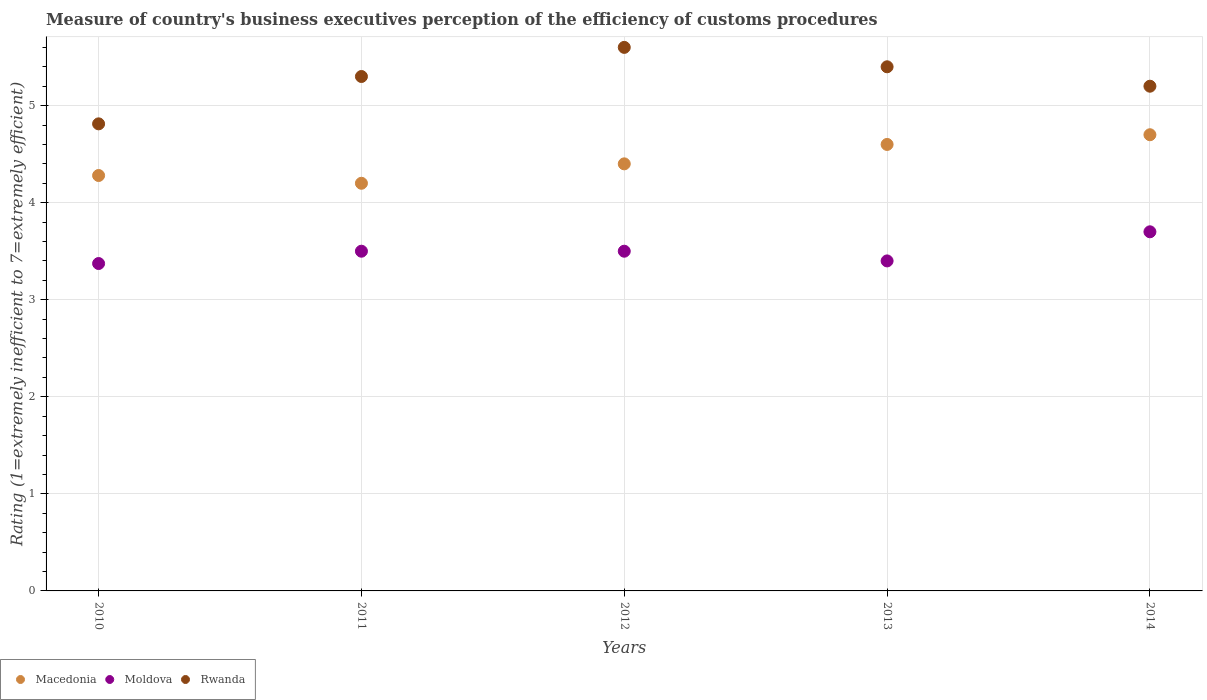Across all years, what is the minimum rating of the efficiency of customs procedure in Moldova?
Your answer should be very brief. 3.37. In which year was the rating of the efficiency of customs procedure in Rwanda minimum?
Make the answer very short. 2010. What is the total rating of the efficiency of customs procedure in Moldova in the graph?
Give a very brief answer. 17.47. What is the difference between the rating of the efficiency of customs procedure in Rwanda in 2011 and that in 2012?
Provide a short and direct response. -0.3. What is the difference between the rating of the efficiency of customs procedure in Moldova in 2014 and the rating of the efficiency of customs procedure in Macedonia in 2012?
Provide a succinct answer. -0.7. What is the average rating of the efficiency of customs procedure in Rwanda per year?
Your response must be concise. 5.26. In the year 2012, what is the difference between the rating of the efficiency of customs procedure in Macedonia and rating of the efficiency of customs procedure in Rwanda?
Provide a short and direct response. -1.2. In how many years, is the rating of the efficiency of customs procedure in Moldova greater than 2.2?
Your answer should be compact. 5. What is the ratio of the rating of the efficiency of customs procedure in Rwanda in 2010 to that in 2013?
Offer a very short reply. 0.89. Is the rating of the efficiency of customs procedure in Rwanda in 2011 less than that in 2012?
Provide a succinct answer. Yes. What is the difference between the highest and the second highest rating of the efficiency of customs procedure in Rwanda?
Provide a succinct answer. 0.2. What is the difference between the highest and the lowest rating of the efficiency of customs procedure in Rwanda?
Make the answer very short. 0.79. Does the rating of the efficiency of customs procedure in Moldova monotonically increase over the years?
Offer a terse response. No. Are the values on the major ticks of Y-axis written in scientific E-notation?
Your response must be concise. No. Does the graph contain any zero values?
Provide a short and direct response. No. Does the graph contain grids?
Your answer should be compact. Yes. How many legend labels are there?
Ensure brevity in your answer.  3. What is the title of the graph?
Make the answer very short. Measure of country's business executives perception of the efficiency of customs procedures. What is the label or title of the X-axis?
Your answer should be compact. Years. What is the label or title of the Y-axis?
Your answer should be very brief. Rating (1=extremely inefficient to 7=extremely efficient). What is the Rating (1=extremely inefficient to 7=extremely efficient) of Macedonia in 2010?
Give a very brief answer. 4.28. What is the Rating (1=extremely inefficient to 7=extremely efficient) of Moldova in 2010?
Your answer should be compact. 3.37. What is the Rating (1=extremely inefficient to 7=extremely efficient) of Rwanda in 2010?
Your answer should be very brief. 4.81. What is the Rating (1=extremely inefficient to 7=extremely efficient) of Macedonia in 2011?
Ensure brevity in your answer.  4.2. What is the Rating (1=extremely inefficient to 7=extremely efficient) in Moldova in 2011?
Offer a terse response. 3.5. What is the Rating (1=extremely inefficient to 7=extremely efficient) of Macedonia in 2014?
Keep it short and to the point. 4.7. What is the Rating (1=extremely inefficient to 7=extremely efficient) of Rwanda in 2014?
Your response must be concise. 5.2. Across all years, what is the maximum Rating (1=extremely inefficient to 7=extremely efficient) of Macedonia?
Give a very brief answer. 4.7. Across all years, what is the maximum Rating (1=extremely inefficient to 7=extremely efficient) in Moldova?
Your answer should be very brief. 3.7. Across all years, what is the maximum Rating (1=extremely inefficient to 7=extremely efficient) in Rwanda?
Provide a succinct answer. 5.6. Across all years, what is the minimum Rating (1=extremely inefficient to 7=extremely efficient) in Macedonia?
Provide a short and direct response. 4.2. Across all years, what is the minimum Rating (1=extremely inefficient to 7=extremely efficient) in Moldova?
Ensure brevity in your answer.  3.37. Across all years, what is the minimum Rating (1=extremely inefficient to 7=extremely efficient) of Rwanda?
Give a very brief answer. 4.81. What is the total Rating (1=extremely inefficient to 7=extremely efficient) of Macedonia in the graph?
Offer a terse response. 22.18. What is the total Rating (1=extremely inefficient to 7=extremely efficient) of Moldova in the graph?
Offer a terse response. 17.47. What is the total Rating (1=extremely inefficient to 7=extremely efficient) in Rwanda in the graph?
Your response must be concise. 26.31. What is the difference between the Rating (1=extremely inefficient to 7=extremely efficient) in Moldova in 2010 and that in 2011?
Offer a terse response. -0.13. What is the difference between the Rating (1=extremely inefficient to 7=extremely efficient) in Rwanda in 2010 and that in 2011?
Your answer should be compact. -0.49. What is the difference between the Rating (1=extremely inefficient to 7=extremely efficient) of Macedonia in 2010 and that in 2012?
Your answer should be compact. -0.12. What is the difference between the Rating (1=extremely inefficient to 7=extremely efficient) in Moldova in 2010 and that in 2012?
Provide a short and direct response. -0.13. What is the difference between the Rating (1=extremely inefficient to 7=extremely efficient) of Rwanda in 2010 and that in 2012?
Keep it short and to the point. -0.79. What is the difference between the Rating (1=extremely inefficient to 7=extremely efficient) of Macedonia in 2010 and that in 2013?
Make the answer very short. -0.32. What is the difference between the Rating (1=extremely inefficient to 7=extremely efficient) in Moldova in 2010 and that in 2013?
Make the answer very short. -0.03. What is the difference between the Rating (1=extremely inefficient to 7=extremely efficient) in Rwanda in 2010 and that in 2013?
Make the answer very short. -0.59. What is the difference between the Rating (1=extremely inefficient to 7=extremely efficient) of Macedonia in 2010 and that in 2014?
Keep it short and to the point. -0.42. What is the difference between the Rating (1=extremely inefficient to 7=extremely efficient) of Moldova in 2010 and that in 2014?
Make the answer very short. -0.33. What is the difference between the Rating (1=extremely inefficient to 7=extremely efficient) in Rwanda in 2010 and that in 2014?
Make the answer very short. -0.39. What is the difference between the Rating (1=extremely inefficient to 7=extremely efficient) in Moldova in 2011 and that in 2012?
Your answer should be compact. 0. What is the difference between the Rating (1=extremely inefficient to 7=extremely efficient) in Moldova in 2011 and that in 2013?
Make the answer very short. 0.1. What is the difference between the Rating (1=extremely inefficient to 7=extremely efficient) of Rwanda in 2011 and that in 2013?
Offer a terse response. -0.1. What is the difference between the Rating (1=extremely inefficient to 7=extremely efficient) of Rwanda in 2011 and that in 2014?
Provide a short and direct response. 0.1. What is the difference between the Rating (1=extremely inefficient to 7=extremely efficient) in Macedonia in 2012 and that in 2013?
Your answer should be compact. -0.2. What is the difference between the Rating (1=extremely inefficient to 7=extremely efficient) of Rwanda in 2012 and that in 2013?
Provide a short and direct response. 0.2. What is the difference between the Rating (1=extremely inefficient to 7=extremely efficient) in Macedonia in 2012 and that in 2014?
Your answer should be very brief. -0.3. What is the difference between the Rating (1=extremely inefficient to 7=extremely efficient) in Rwanda in 2012 and that in 2014?
Your response must be concise. 0.4. What is the difference between the Rating (1=extremely inefficient to 7=extremely efficient) of Macedonia in 2013 and that in 2014?
Offer a very short reply. -0.1. What is the difference between the Rating (1=extremely inefficient to 7=extremely efficient) in Moldova in 2013 and that in 2014?
Ensure brevity in your answer.  -0.3. What is the difference between the Rating (1=extremely inefficient to 7=extremely efficient) of Macedonia in 2010 and the Rating (1=extremely inefficient to 7=extremely efficient) of Moldova in 2011?
Offer a terse response. 0.78. What is the difference between the Rating (1=extremely inefficient to 7=extremely efficient) in Macedonia in 2010 and the Rating (1=extremely inefficient to 7=extremely efficient) in Rwanda in 2011?
Offer a terse response. -1.02. What is the difference between the Rating (1=extremely inefficient to 7=extremely efficient) of Moldova in 2010 and the Rating (1=extremely inefficient to 7=extremely efficient) of Rwanda in 2011?
Provide a succinct answer. -1.93. What is the difference between the Rating (1=extremely inefficient to 7=extremely efficient) in Macedonia in 2010 and the Rating (1=extremely inefficient to 7=extremely efficient) in Moldova in 2012?
Your response must be concise. 0.78. What is the difference between the Rating (1=extremely inefficient to 7=extremely efficient) of Macedonia in 2010 and the Rating (1=extremely inefficient to 7=extremely efficient) of Rwanda in 2012?
Your answer should be compact. -1.32. What is the difference between the Rating (1=extremely inefficient to 7=extremely efficient) of Moldova in 2010 and the Rating (1=extremely inefficient to 7=extremely efficient) of Rwanda in 2012?
Keep it short and to the point. -2.23. What is the difference between the Rating (1=extremely inefficient to 7=extremely efficient) of Macedonia in 2010 and the Rating (1=extremely inefficient to 7=extremely efficient) of Rwanda in 2013?
Your answer should be compact. -1.12. What is the difference between the Rating (1=extremely inefficient to 7=extremely efficient) of Moldova in 2010 and the Rating (1=extremely inefficient to 7=extremely efficient) of Rwanda in 2013?
Offer a terse response. -2.03. What is the difference between the Rating (1=extremely inefficient to 7=extremely efficient) of Macedonia in 2010 and the Rating (1=extremely inefficient to 7=extremely efficient) of Moldova in 2014?
Offer a very short reply. 0.58. What is the difference between the Rating (1=extremely inefficient to 7=extremely efficient) in Macedonia in 2010 and the Rating (1=extremely inefficient to 7=extremely efficient) in Rwanda in 2014?
Keep it short and to the point. -0.92. What is the difference between the Rating (1=extremely inefficient to 7=extremely efficient) of Moldova in 2010 and the Rating (1=extremely inefficient to 7=extremely efficient) of Rwanda in 2014?
Your answer should be very brief. -1.83. What is the difference between the Rating (1=extremely inefficient to 7=extremely efficient) in Macedonia in 2011 and the Rating (1=extremely inefficient to 7=extremely efficient) in Rwanda in 2012?
Give a very brief answer. -1.4. What is the difference between the Rating (1=extremely inefficient to 7=extremely efficient) of Macedonia in 2011 and the Rating (1=extremely inefficient to 7=extremely efficient) of Rwanda in 2013?
Your response must be concise. -1.2. What is the difference between the Rating (1=extremely inefficient to 7=extremely efficient) in Macedonia in 2011 and the Rating (1=extremely inefficient to 7=extremely efficient) in Moldova in 2014?
Make the answer very short. 0.5. What is the difference between the Rating (1=extremely inefficient to 7=extremely efficient) in Macedonia in 2011 and the Rating (1=extremely inefficient to 7=extremely efficient) in Rwanda in 2014?
Ensure brevity in your answer.  -1. What is the difference between the Rating (1=extremely inefficient to 7=extremely efficient) of Macedonia in 2012 and the Rating (1=extremely inefficient to 7=extremely efficient) of Moldova in 2013?
Your answer should be compact. 1. What is the difference between the Rating (1=extremely inefficient to 7=extremely efficient) in Macedonia in 2012 and the Rating (1=extremely inefficient to 7=extremely efficient) in Rwanda in 2013?
Give a very brief answer. -1. What is the difference between the Rating (1=extremely inefficient to 7=extremely efficient) in Moldova in 2012 and the Rating (1=extremely inefficient to 7=extremely efficient) in Rwanda in 2014?
Provide a succinct answer. -1.7. What is the difference between the Rating (1=extremely inefficient to 7=extremely efficient) in Macedonia in 2013 and the Rating (1=extremely inefficient to 7=extremely efficient) in Rwanda in 2014?
Offer a terse response. -0.6. What is the average Rating (1=extremely inefficient to 7=extremely efficient) of Macedonia per year?
Provide a short and direct response. 4.44. What is the average Rating (1=extremely inefficient to 7=extremely efficient) of Moldova per year?
Offer a terse response. 3.49. What is the average Rating (1=extremely inefficient to 7=extremely efficient) in Rwanda per year?
Keep it short and to the point. 5.26. In the year 2010, what is the difference between the Rating (1=extremely inefficient to 7=extremely efficient) of Macedonia and Rating (1=extremely inefficient to 7=extremely efficient) of Moldova?
Make the answer very short. 0.91. In the year 2010, what is the difference between the Rating (1=extremely inefficient to 7=extremely efficient) of Macedonia and Rating (1=extremely inefficient to 7=extremely efficient) of Rwanda?
Keep it short and to the point. -0.53. In the year 2010, what is the difference between the Rating (1=extremely inefficient to 7=extremely efficient) of Moldova and Rating (1=extremely inefficient to 7=extremely efficient) of Rwanda?
Keep it short and to the point. -1.44. In the year 2011, what is the difference between the Rating (1=extremely inefficient to 7=extremely efficient) in Macedonia and Rating (1=extremely inefficient to 7=extremely efficient) in Moldova?
Give a very brief answer. 0.7. In the year 2011, what is the difference between the Rating (1=extremely inefficient to 7=extremely efficient) in Macedonia and Rating (1=extremely inefficient to 7=extremely efficient) in Rwanda?
Give a very brief answer. -1.1. In the year 2011, what is the difference between the Rating (1=extremely inefficient to 7=extremely efficient) of Moldova and Rating (1=extremely inefficient to 7=extremely efficient) of Rwanda?
Your response must be concise. -1.8. In the year 2012, what is the difference between the Rating (1=extremely inefficient to 7=extremely efficient) of Macedonia and Rating (1=extremely inefficient to 7=extremely efficient) of Moldova?
Offer a very short reply. 0.9. In the year 2013, what is the difference between the Rating (1=extremely inefficient to 7=extremely efficient) in Macedonia and Rating (1=extremely inefficient to 7=extremely efficient) in Moldova?
Your response must be concise. 1.2. In the year 2014, what is the difference between the Rating (1=extremely inefficient to 7=extremely efficient) in Moldova and Rating (1=extremely inefficient to 7=extremely efficient) in Rwanda?
Make the answer very short. -1.5. What is the ratio of the Rating (1=extremely inefficient to 7=extremely efficient) in Moldova in 2010 to that in 2011?
Ensure brevity in your answer.  0.96. What is the ratio of the Rating (1=extremely inefficient to 7=extremely efficient) in Rwanda in 2010 to that in 2011?
Your answer should be compact. 0.91. What is the ratio of the Rating (1=extremely inefficient to 7=extremely efficient) of Macedonia in 2010 to that in 2012?
Offer a terse response. 0.97. What is the ratio of the Rating (1=extremely inefficient to 7=extremely efficient) in Moldova in 2010 to that in 2012?
Keep it short and to the point. 0.96. What is the ratio of the Rating (1=extremely inefficient to 7=extremely efficient) of Rwanda in 2010 to that in 2012?
Give a very brief answer. 0.86. What is the ratio of the Rating (1=extremely inefficient to 7=extremely efficient) in Macedonia in 2010 to that in 2013?
Your response must be concise. 0.93. What is the ratio of the Rating (1=extremely inefficient to 7=extremely efficient) of Moldova in 2010 to that in 2013?
Make the answer very short. 0.99. What is the ratio of the Rating (1=extremely inefficient to 7=extremely efficient) of Rwanda in 2010 to that in 2013?
Give a very brief answer. 0.89. What is the ratio of the Rating (1=extremely inefficient to 7=extremely efficient) of Macedonia in 2010 to that in 2014?
Your answer should be very brief. 0.91. What is the ratio of the Rating (1=extremely inefficient to 7=extremely efficient) in Moldova in 2010 to that in 2014?
Ensure brevity in your answer.  0.91. What is the ratio of the Rating (1=extremely inefficient to 7=extremely efficient) in Rwanda in 2010 to that in 2014?
Ensure brevity in your answer.  0.93. What is the ratio of the Rating (1=extremely inefficient to 7=extremely efficient) in Macedonia in 2011 to that in 2012?
Your response must be concise. 0.95. What is the ratio of the Rating (1=extremely inefficient to 7=extremely efficient) of Moldova in 2011 to that in 2012?
Offer a terse response. 1. What is the ratio of the Rating (1=extremely inefficient to 7=extremely efficient) of Rwanda in 2011 to that in 2012?
Your answer should be very brief. 0.95. What is the ratio of the Rating (1=extremely inefficient to 7=extremely efficient) in Moldova in 2011 to that in 2013?
Offer a very short reply. 1.03. What is the ratio of the Rating (1=extremely inefficient to 7=extremely efficient) in Rwanda in 2011 to that in 2013?
Your answer should be compact. 0.98. What is the ratio of the Rating (1=extremely inefficient to 7=extremely efficient) in Macedonia in 2011 to that in 2014?
Your answer should be compact. 0.89. What is the ratio of the Rating (1=extremely inefficient to 7=extremely efficient) in Moldova in 2011 to that in 2014?
Your answer should be very brief. 0.95. What is the ratio of the Rating (1=extremely inefficient to 7=extremely efficient) of Rwanda in 2011 to that in 2014?
Provide a short and direct response. 1.02. What is the ratio of the Rating (1=extremely inefficient to 7=extremely efficient) in Macedonia in 2012 to that in 2013?
Offer a terse response. 0.96. What is the ratio of the Rating (1=extremely inefficient to 7=extremely efficient) of Moldova in 2012 to that in 2013?
Provide a succinct answer. 1.03. What is the ratio of the Rating (1=extremely inefficient to 7=extremely efficient) in Macedonia in 2012 to that in 2014?
Ensure brevity in your answer.  0.94. What is the ratio of the Rating (1=extremely inefficient to 7=extremely efficient) of Moldova in 2012 to that in 2014?
Make the answer very short. 0.95. What is the ratio of the Rating (1=extremely inefficient to 7=extremely efficient) of Macedonia in 2013 to that in 2014?
Keep it short and to the point. 0.98. What is the ratio of the Rating (1=extremely inefficient to 7=extremely efficient) of Moldova in 2013 to that in 2014?
Give a very brief answer. 0.92. What is the difference between the highest and the second highest Rating (1=extremely inefficient to 7=extremely efficient) in Macedonia?
Give a very brief answer. 0.1. What is the difference between the highest and the second highest Rating (1=extremely inefficient to 7=extremely efficient) in Rwanda?
Give a very brief answer. 0.2. What is the difference between the highest and the lowest Rating (1=extremely inefficient to 7=extremely efficient) in Macedonia?
Your response must be concise. 0.5. What is the difference between the highest and the lowest Rating (1=extremely inefficient to 7=extremely efficient) of Moldova?
Give a very brief answer. 0.33. What is the difference between the highest and the lowest Rating (1=extremely inefficient to 7=extremely efficient) of Rwanda?
Make the answer very short. 0.79. 